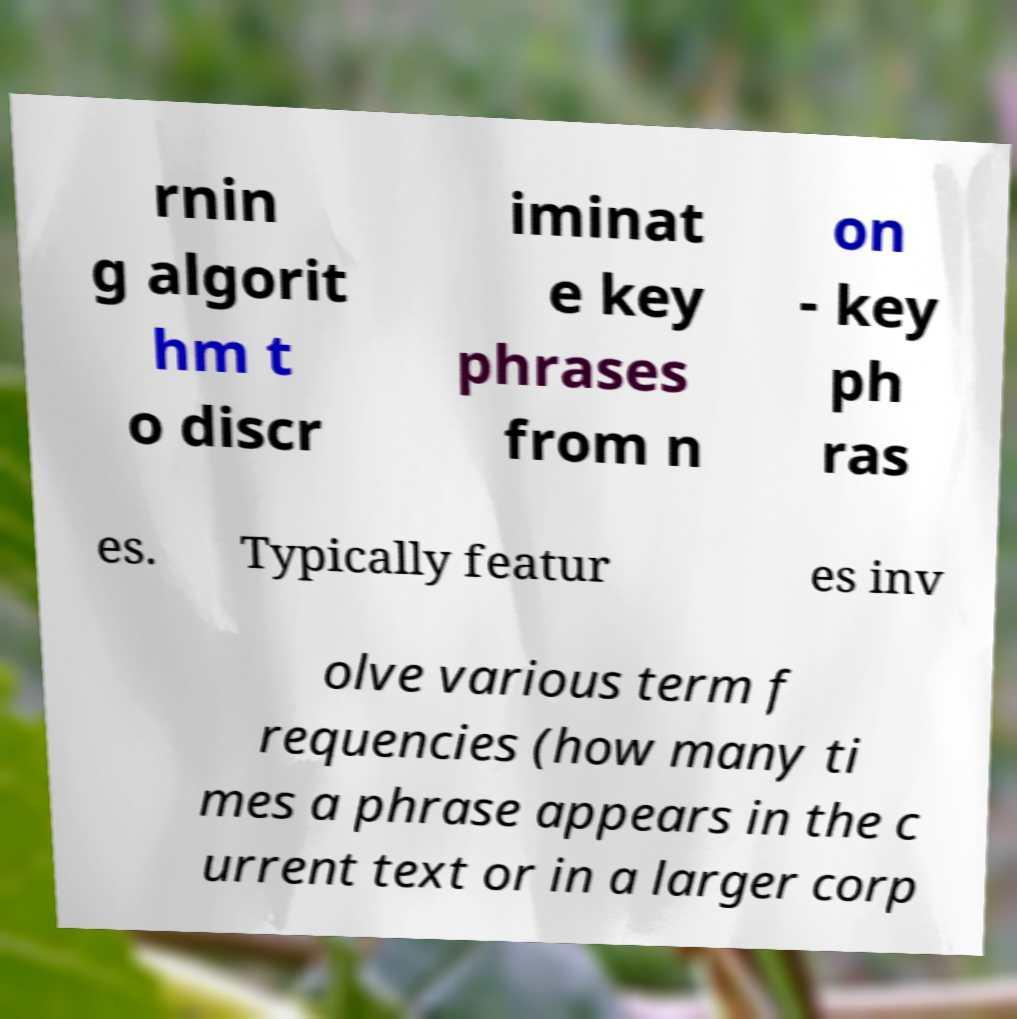Can you accurately transcribe the text from the provided image for me? rnin g algorit hm t o discr iminat e key phrases from n on - key ph ras es. Typically featur es inv olve various term f requencies (how many ti mes a phrase appears in the c urrent text or in a larger corp 